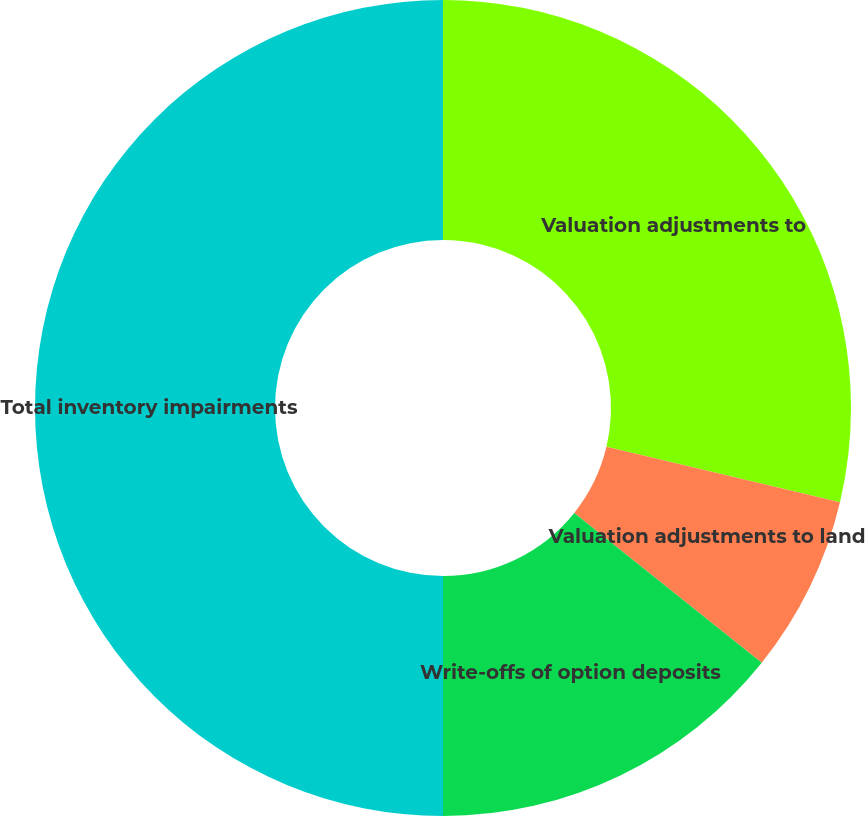<chart> <loc_0><loc_0><loc_500><loc_500><pie_chart><fcel>Valuation adjustments to<fcel>Valuation adjustments to land<fcel>Write-offs of option deposits<fcel>Total inventory impairments<nl><fcel>28.71%<fcel>7.02%<fcel>14.27%<fcel>50.0%<nl></chart> 